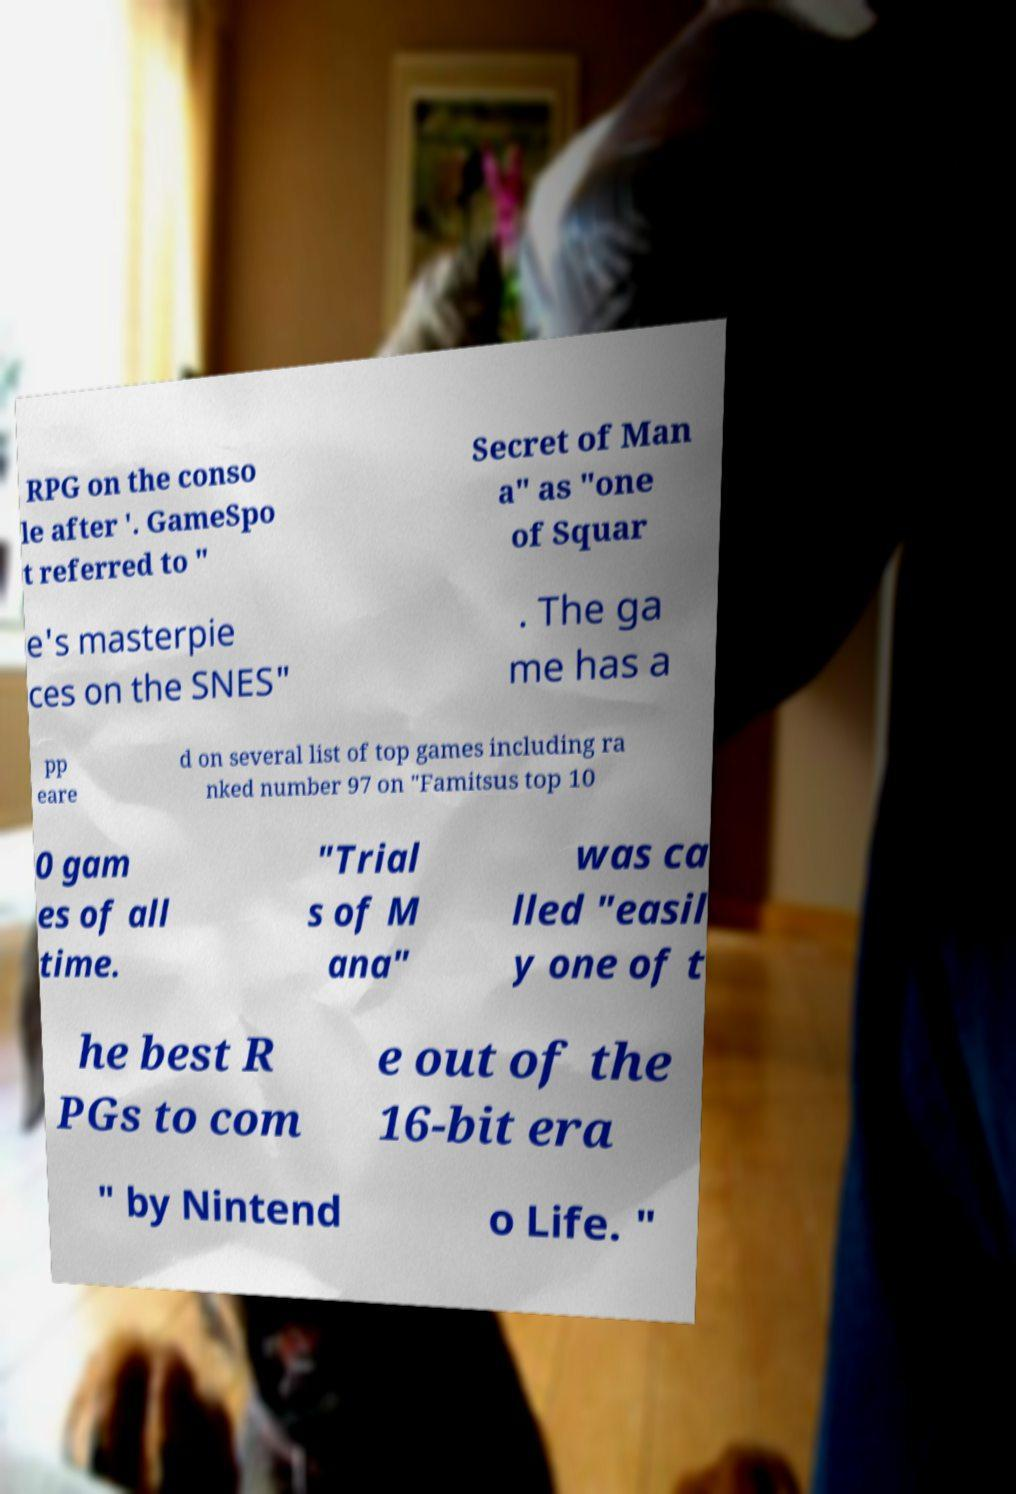Could you extract and type out the text from this image? RPG on the conso le after '. GameSpo t referred to " Secret of Man a" as "one of Squar e's masterpie ces on the SNES" . The ga me has a pp eare d on several list of top games including ra nked number 97 on "Famitsus top 10 0 gam es of all time. "Trial s of M ana" was ca lled "easil y one of t he best R PGs to com e out of the 16-bit era " by Nintend o Life. " 